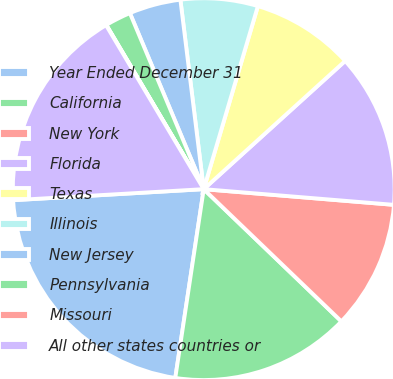Convert chart to OTSL. <chart><loc_0><loc_0><loc_500><loc_500><pie_chart><fcel>Year Ended December 31<fcel>California<fcel>New York<fcel>Florida<fcel>Texas<fcel>Illinois<fcel>New Jersey<fcel>Pennsylvania<fcel>Missouri<fcel>All other states countries or<nl><fcel>21.7%<fcel>15.2%<fcel>10.87%<fcel>13.03%<fcel>8.7%<fcel>6.53%<fcel>4.37%<fcel>2.2%<fcel>0.03%<fcel>17.37%<nl></chart> 